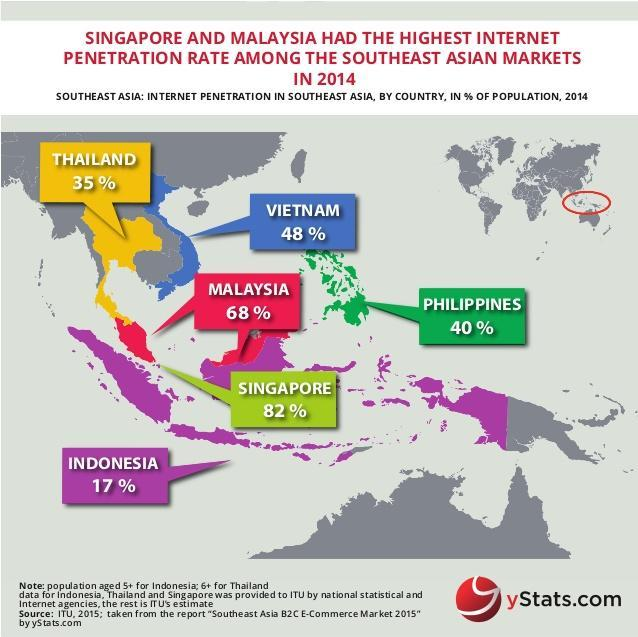Which is the region circled in red, Americas, Middle East, Western Europe, or South East Asia?
Answer the question with a short phrase. South East Asia Which are the countries with more than 30% and less than 50% penetration Thailand, Vietnam, Philippines Which are the top 2 countries with the highest internet penetration Singapore and Malaysia Which country is shown in blue Vietnam 